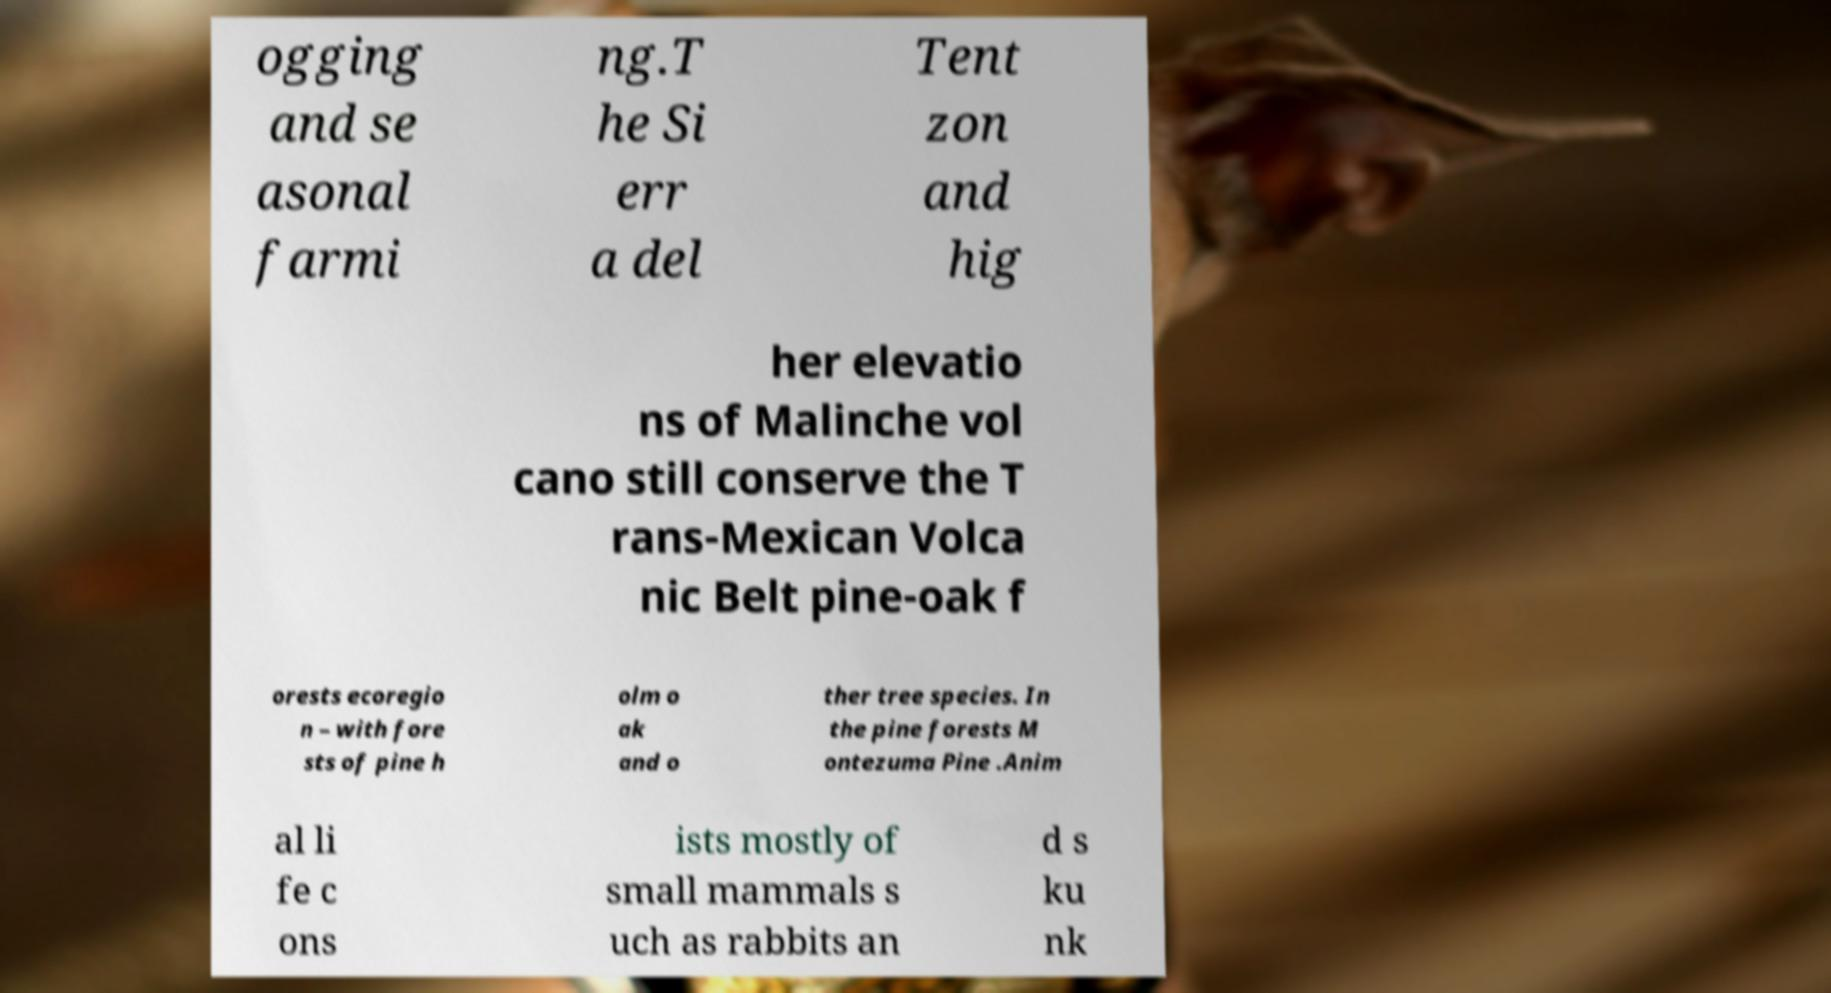Can you read and provide the text displayed in the image?This photo seems to have some interesting text. Can you extract and type it out for me? ogging and se asonal farmi ng.T he Si err a del Tent zon and hig her elevatio ns of Malinche vol cano still conserve the T rans-Mexican Volca nic Belt pine-oak f orests ecoregio n – with fore sts of pine h olm o ak and o ther tree species. In the pine forests M ontezuma Pine .Anim al li fe c ons ists mostly of small mammals s uch as rabbits an d s ku nk 